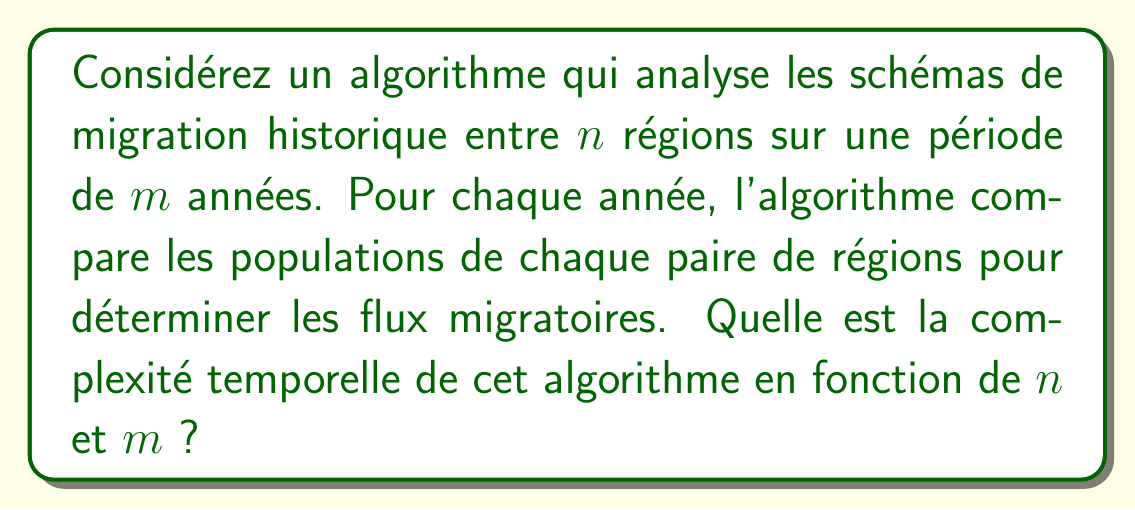Could you help me with this problem? Pour résoudre ce problème, suivons ces étapes :

1) D'abord, analysons la structure de l'algorithme :
   - Il y a $m$ années à analyser.
   - Pour chaque année, nous comparons chaque paire de régions.

2) Calculons le nombre de comparaisons pour une seule année :
   - Il y a $n$ régions.
   - Pour comparer chaque paire, nous devons faire $\frac{n(n-1)}{2}$ comparaisons.
   - Cette formule vient du fait que pour $n$ éléments, le nombre de paires uniques est $\frac{n(n-1)}{2}$.

3) Maintenant, considérons toutes les années :
   - Nous répétons ces comparaisons pour chacune des $m$ années.
   - Donc, le nombre total de comparaisons est : $m \cdot \frac{n(n-1)}{2}$

4) Simplifions cette expression :
   $$m \cdot \frac{n(n-1)}{2} = \frac{mn(n-1)}{2}$$

5) En termes de notation Big O, nous nous intéressons au terme de croissance le plus rapide :
   - $n(n-1)$ se développe en $n^2 - n$
   - Le terme dominant est $n^2$
   - Le facteur constant $\frac{1}{2}$ est ignoré en notation Big O

Donc, la complexité temporelle est de l'ordre de $O(mn^2)$.
Answer: $O(mn^2)$ 